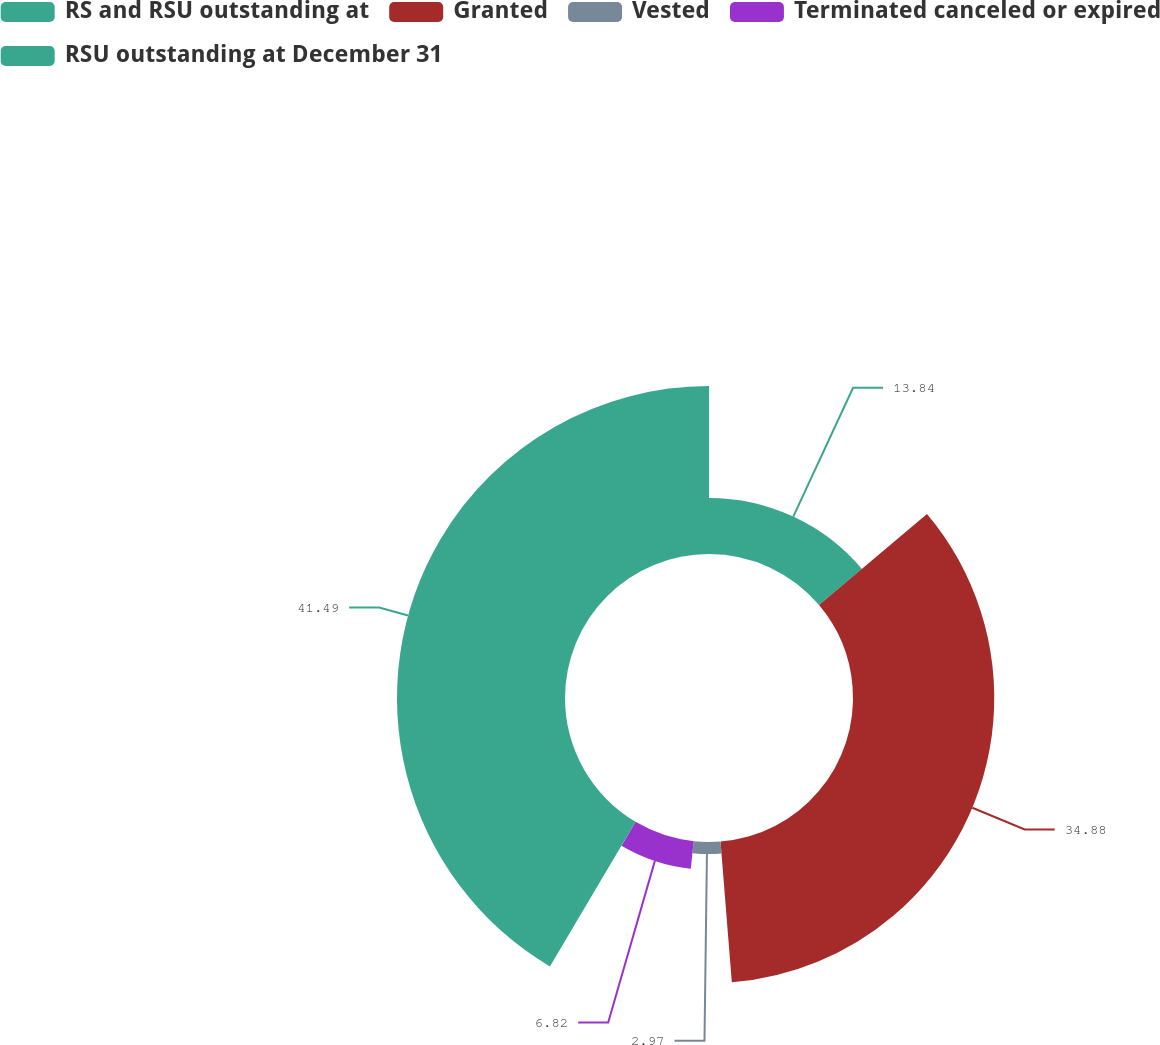Convert chart to OTSL. <chart><loc_0><loc_0><loc_500><loc_500><pie_chart><fcel>RS and RSU outstanding at<fcel>Granted<fcel>Vested<fcel>Terminated canceled or expired<fcel>RSU outstanding at December 31<nl><fcel>13.84%<fcel>34.88%<fcel>2.97%<fcel>6.82%<fcel>41.48%<nl></chart> 